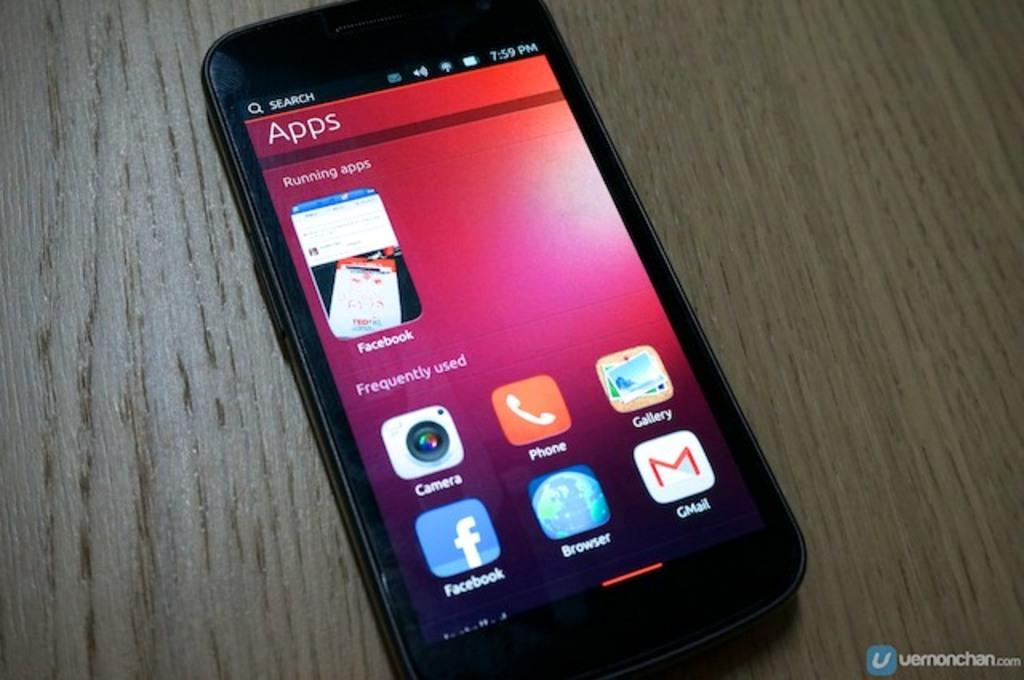<image>
Write a terse but informative summary of the picture. Below the search bar on a phone is a page of apps. 